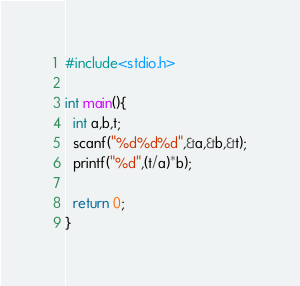Convert code to text. <code><loc_0><loc_0><loc_500><loc_500><_C_>#include<stdio.h>

int main(){
  int a,b,t;
  scanf("%d%d%d",&a,&b,&t);
  printf("%d",(t/a)*b);

  return 0;
}</code> 